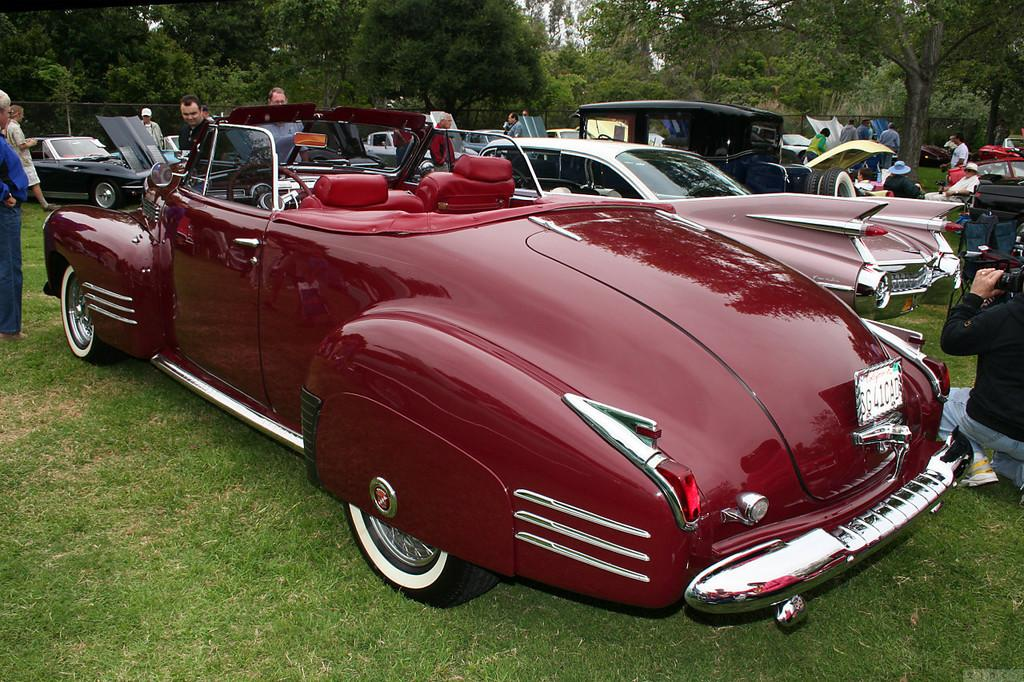How many people are in the image? There are people in the image, but the exact number is not specified. What are the people in the image doing? Some people are sitting, while others are standing. What else can be seen on the ground in the image? There are vehicles on the ground. What type of vegetation is present in the image? There are trees in the image. What is the purpose of the fence in the image? The purpose of the fence is not specified, but it is present in the image. What is visible in the sky in the image? The sky is visible in the image. What is the chance of a frog hopping across the office in the image? There is no office or frog present in the image, so it is not possible to determine the chance of a frog hopping across an office. 